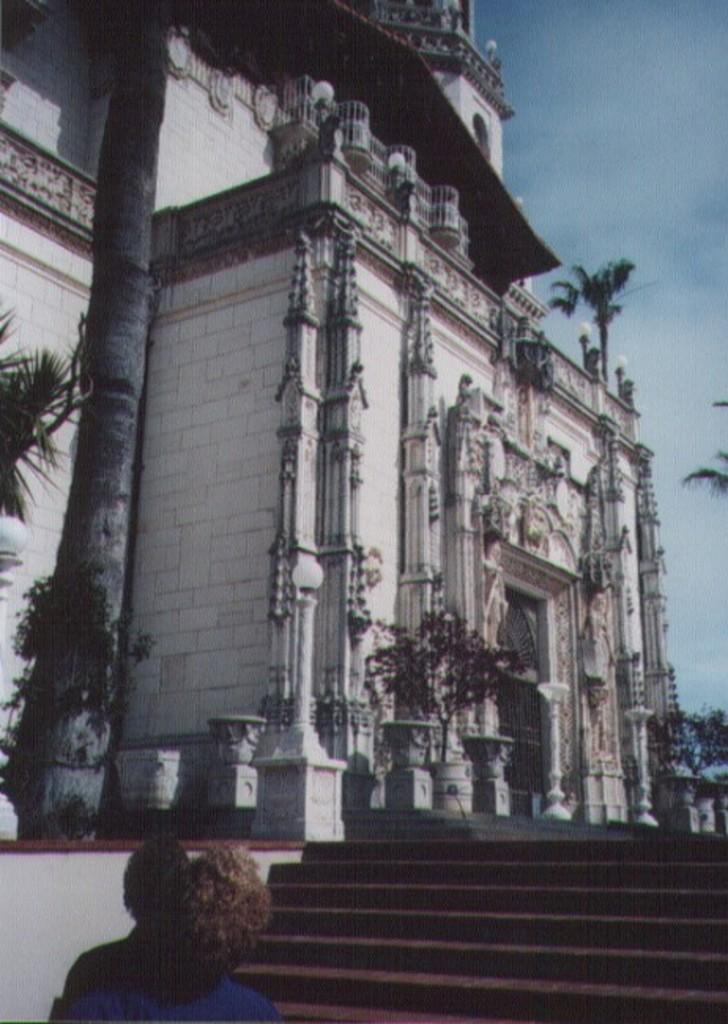In one or two sentences, can you explain what this image depicts? In this image I can see few stairs, plants in green color, building in white color. At top sky is in blue and white color. 